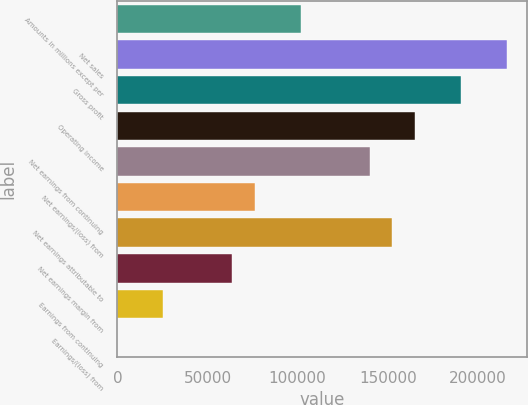Convert chart to OTSL. <chart><loc_0><loc_0><loc_500><loc_500><bar_chart><fcel>Amounts in millions except per<fcel>Net sales<fcel>Gross profit<fcel>Operating income<fcel>Net earnings from continuing<fcel>Net earnings/(loss) from<fcel>Net earnings attributable to<fcel>Net earnings margin from<fcel>Earnings from continuing<fcel>Earnings/(loss) from<nl><fcel>101709<fcel>216131<fcel>190704<fcel>165277<fcel>139850<fcel>76281.7<fcel>152563<fcel>63568.1<fcel>25427.4<fcel>0.21<nl></chart> 